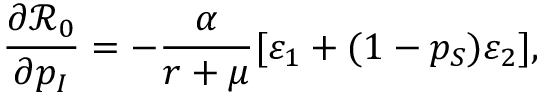Convert formula to latex. <formula><loc_0><loc_0><loc_500><loc_500>\frac { \partial \mathcal { R } _ { 0 } } { \partial p _ { I } } = - \frac { \alpha } { r + \mu } [ \varepsilon _ { 1 } + ( 1 - p _ { S } ) \varepsilon _ { 2 } ] ,</formula> 